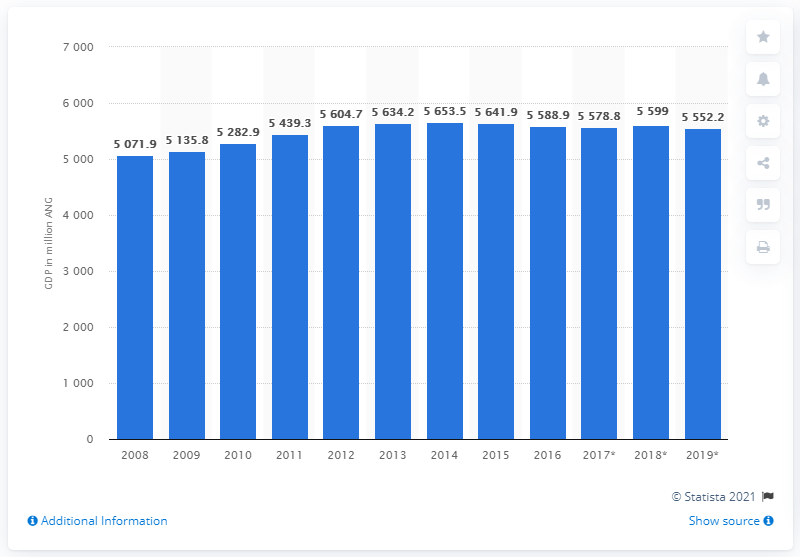Mention a couple of crucial points in this snapshot. According to data from 2014, the Gross Domestic Product (GDP) of Curaao was 5,552.2 million. The Gross Domestic Product of Curaao was 5,552.2 million from 2008 to 2019. 